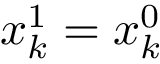<formula> <loc_0><loc_0><loc_500><loc_500>x _ { k } ^ { 1 } = x _ { k } ^ { 0 }</formula> 